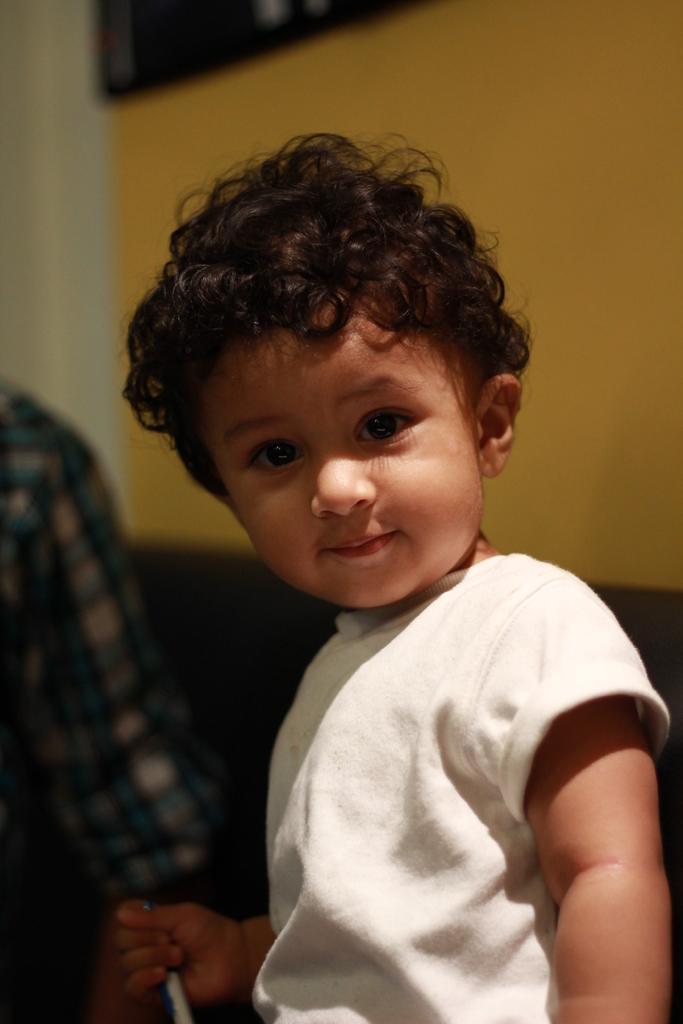Please provide a concise description of this image. In this image we can see child holding one object. And we can see the wall. 